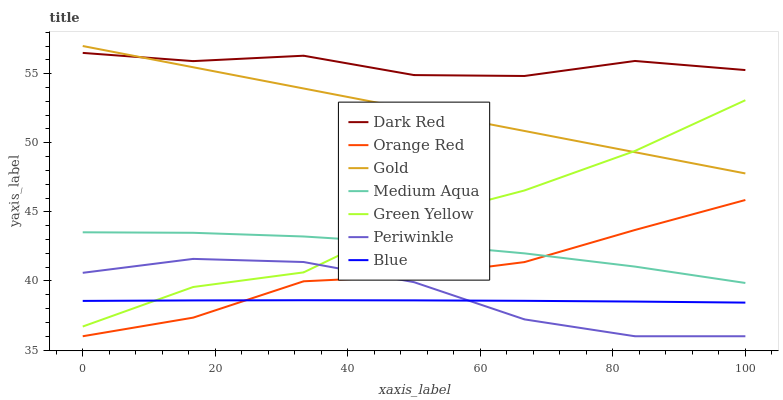Does Blue have the minimum area under the curve?
Answer yes or no. Yes. Does Dark Red have the maximum area under the curve?
Answer yes or no. Yes. Does Gold have the minimum area under the curve?
Answer yes or no. No. Does Gold have the maximum area under the curve?
Answer yes or no. No. Is Gold the smoothest?
Answer yes or no. Yes. Is Green Yellow the roughest?
Answer yes or no. Yes. Is Dark Red the smoothest?
Answer yes or no. No. Is Dark Red the roughest?
Answer yes or no. No. Does Periwinkle have the lowest value?
Answer yes or no. Yes. Does Gold have the lowest value?
Answer yes or no. No. Does Gold have the highest value?
Answer yes or no. Yes. Does Dark Red have the highest value?
Answer yes or no. No. Is Orange Red less than Dark Red?
Answer yes or no. Yes. Is Dark Red greater than Periwinkle?
Answer yes or no. Yes. Does Blue intersect Orange Red?
Answer yes or no. Yes. Is Blue less than Orange Red?
Answer yes or no. No. Is Blue greater than Orange Red?
Answer yes or no. No. Does Orange Red intersect Dark Red?
Answer yes or no. No. 